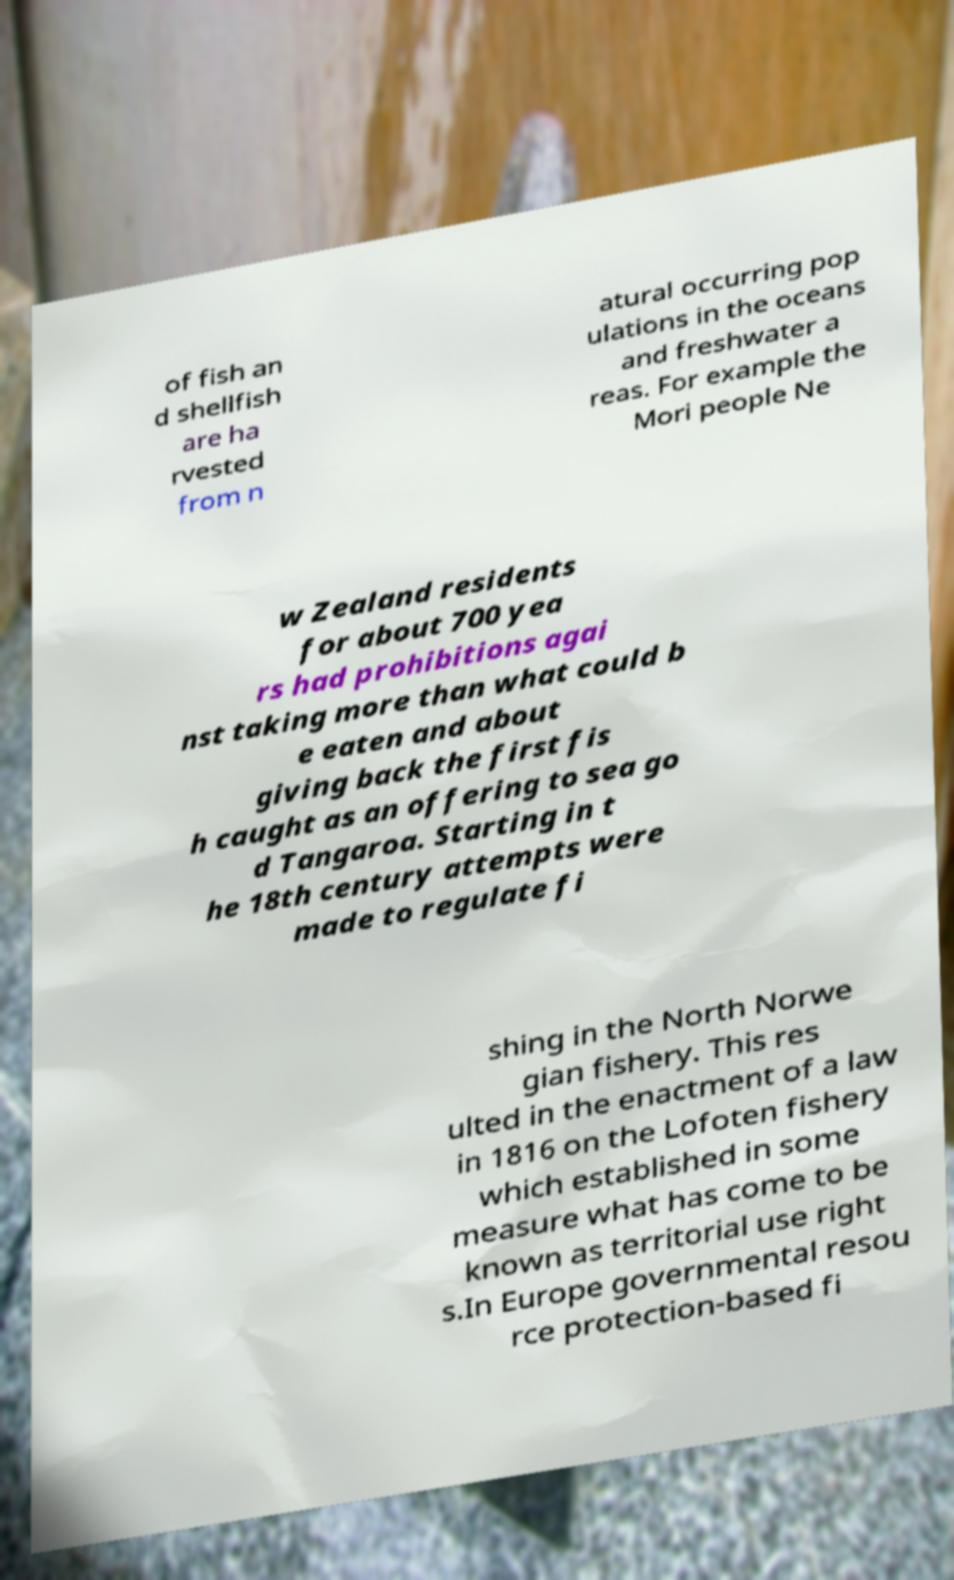Please identify and transcribe the text found in this image. of fish an d shellfish are ha rvested from n atural occurring pop ulations in the oceans and freshwater a reas. For example the Mori people Ne w Zealand residents for about 700 yea rs had prohibitions agai nst taking more than what could b e eaten and about giving back the first fis h caught as an offering to sea go d Tangaroa. Starting in t he 18th century attempts were made to regulate fi shing in the North Norwe gian fishery. This res ulted in the enactment of a law in 1816 on the Lofoten fishery which established in some measure what has come to be known as territorial use right s.In Europe governmental resou rce protection-based fi 